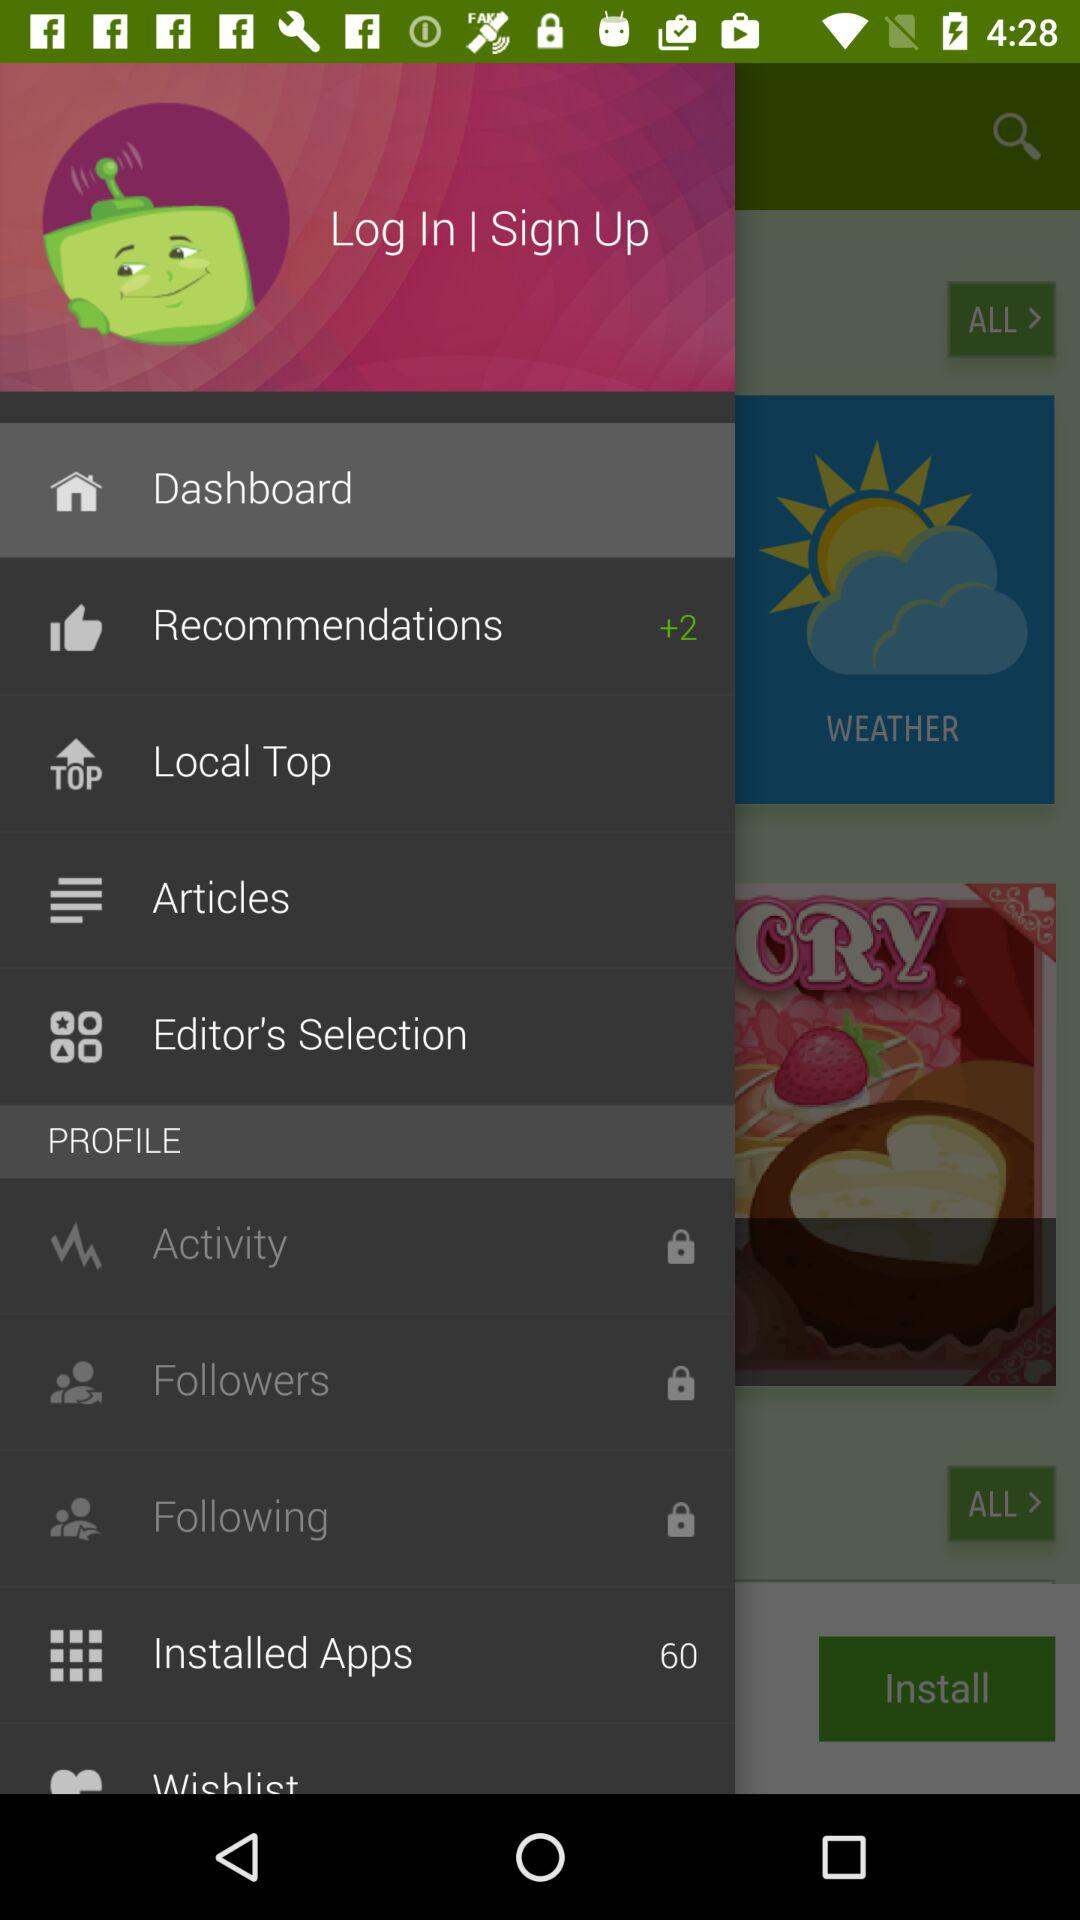How many recommendations are there? There are 2 recommendations. 